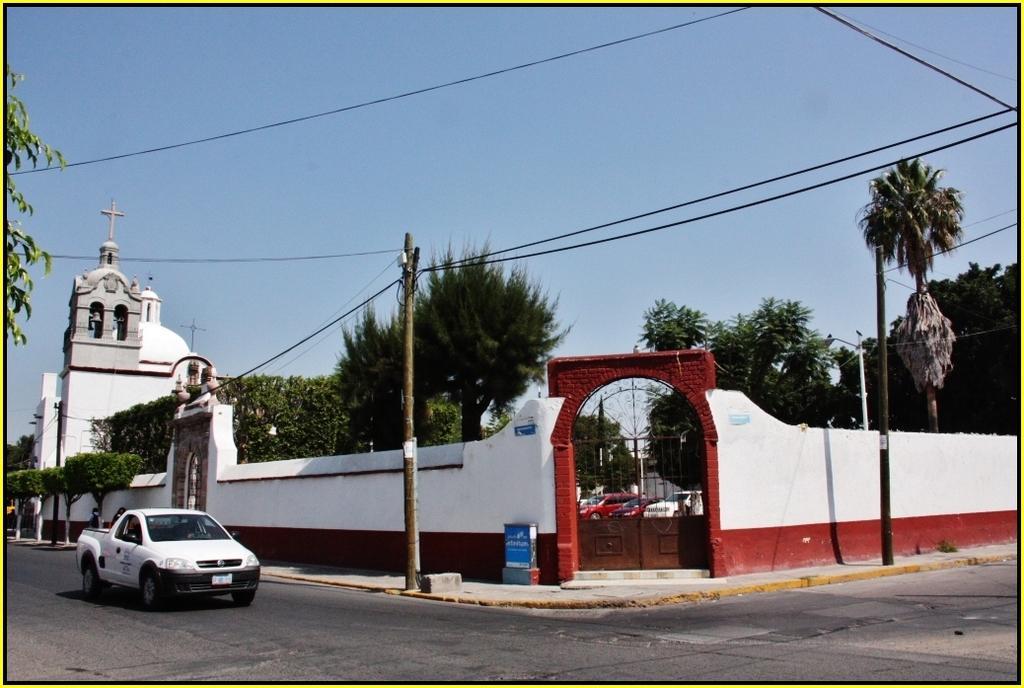Could you give a brief overview of what you see in this image? This is an outside view. On the left side there is a vehicle on the road and a building. Beside the road there is a wall. In the background there are many trees. At the top of the image I can see the sky and also there are few cables. Here I can see few poles. 